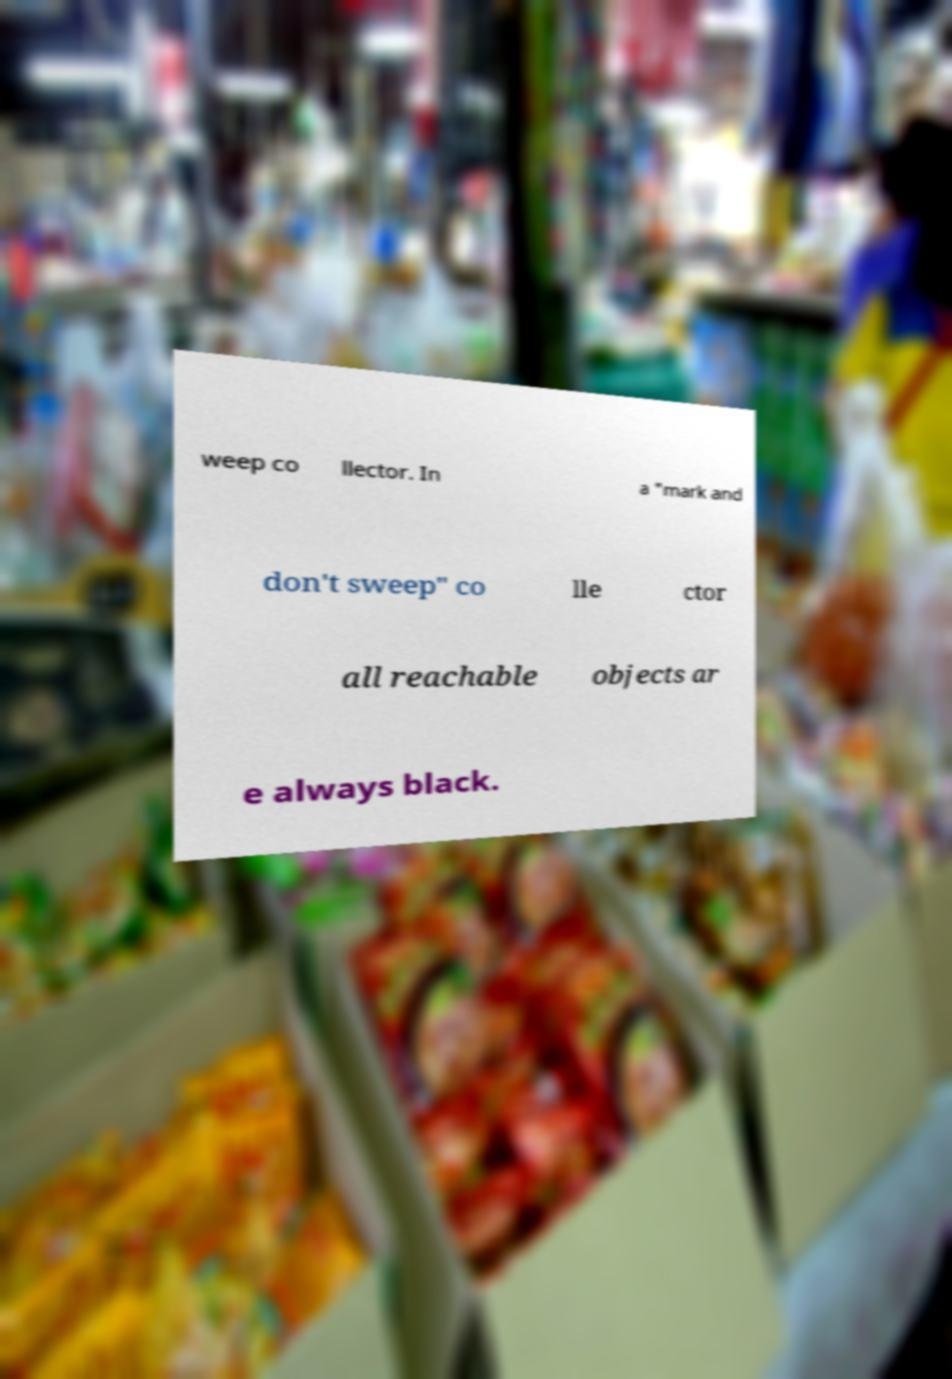Please identify and transcribe the text found in this image. weep co llector. In a "mark and don't sweep" co lle ctor all reachable objects ar e always black. 